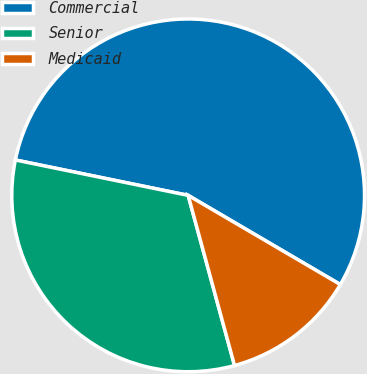<chart> <loc_0><loc_0><loc_500><loc_500><pie_chart><fcel>Commercial<fcel>Senior<fcel>Medicaid<nl><fcel>55.22%<fcel>32.45%<fcel>12.33%<nl></chart> 